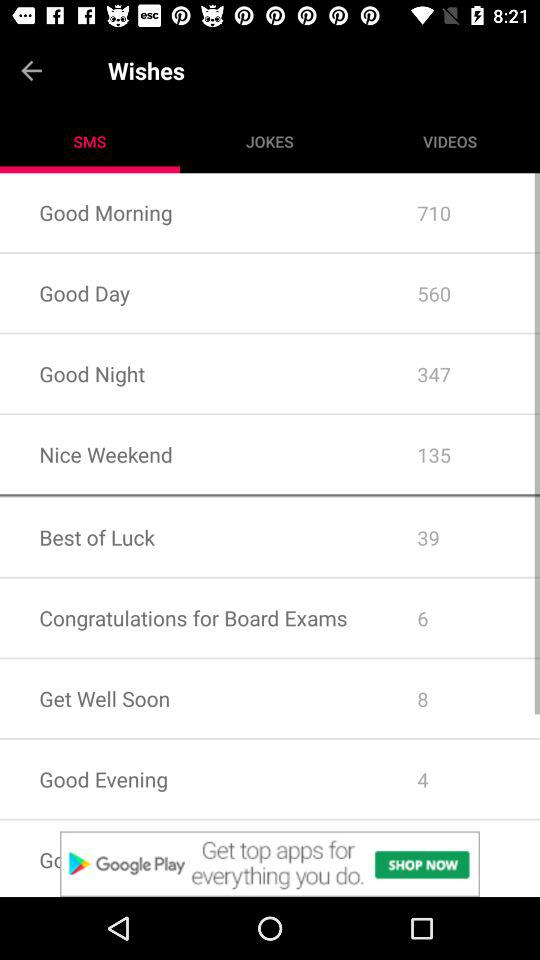How many messages of "Best of Luck" are there? There are 39 messages of "Best of Luck". 